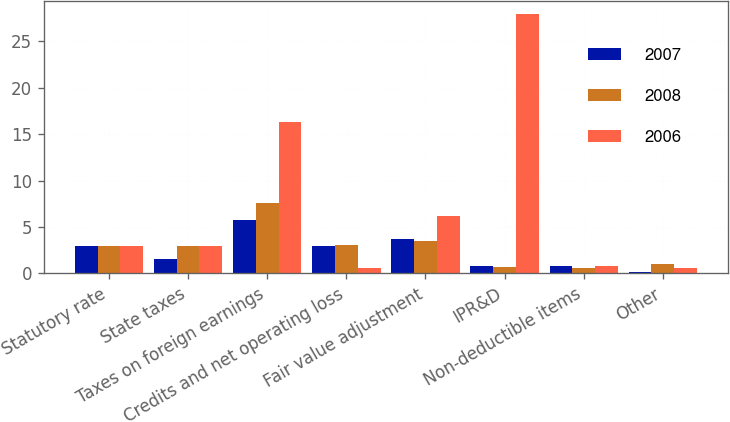Convert chart. <chart><loc_0><loc_0><loc_500><loc_500><stacked_bar_chart><ecel><fcel>Statutory rate<fcel>State taxes<fcel>Taxes on foreign earnings<fcel>Credits and net operating loss<fcel>Fair value adjustment<fcel>IPR&D<fcel>Non-deductible items<fcel>Other<nl><fcel>2007<fcel>2.9<fcel>1.6<fcel>5.8<fcel>2.9<fcel>3.7<fcel>0.8<fcel>0.8<fcel>0.2<nl><fcel>2008<fcel>2.9<fcel>3<fcel>7.6<fcel>3.1<fcel>3.5<fcel>0.7<fcel>0.6<fcel>1<nl><fcel>2006<fcel>2.9<fcel>3<fcel>16.3<fcel>0.6<fcel>6.2<fcel>27.9<fcel>0.8<fcel>0.6<nl></chart> 